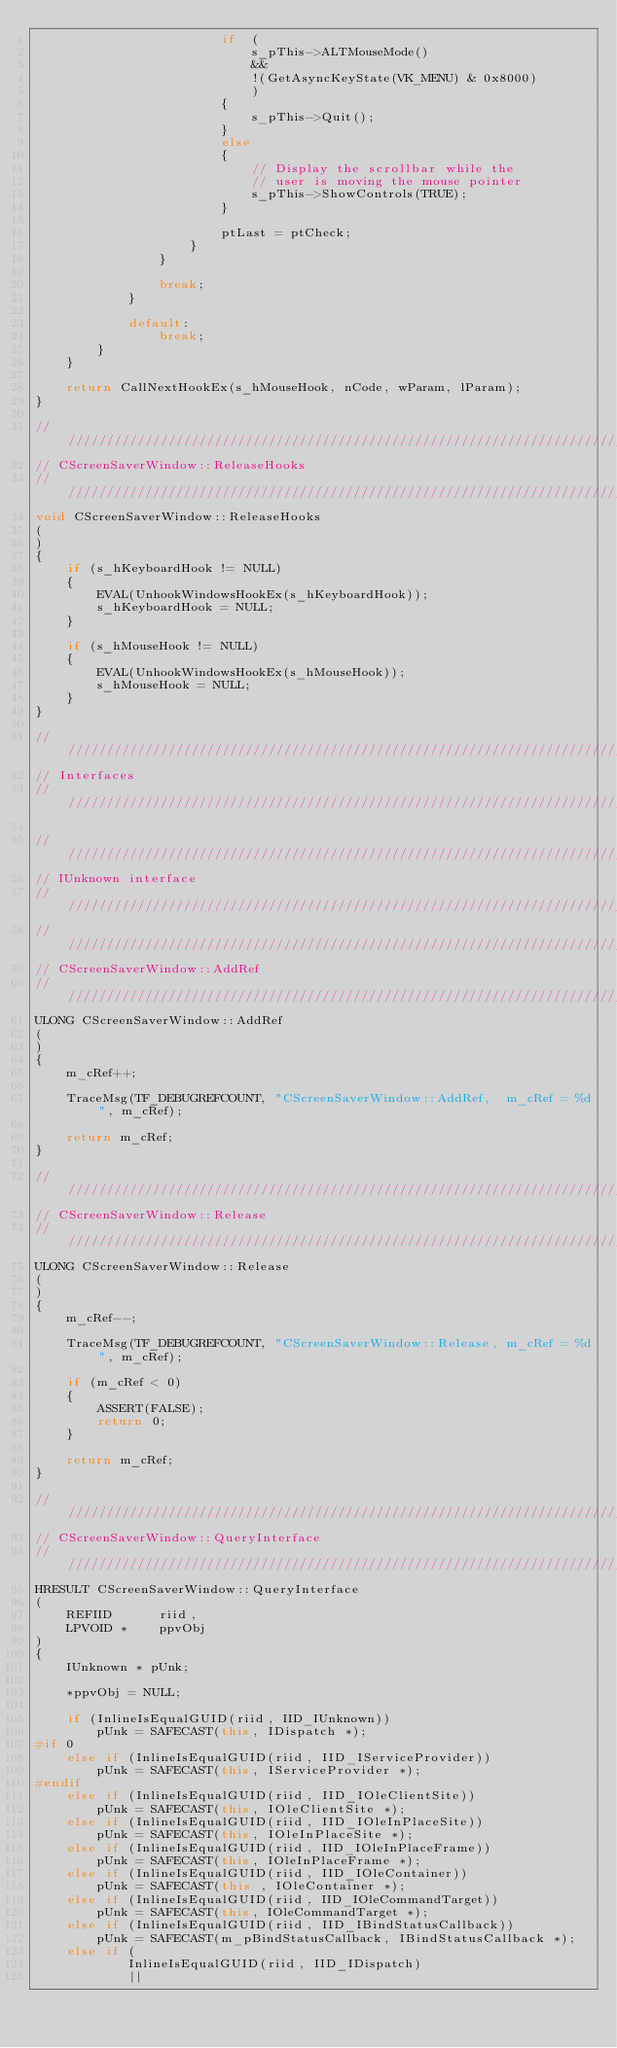Convert code to text. <code><loc_0><loc_0><loc_500><loc_500><_C++_>                        if  (
                            s_pThis->ALTMouseMode()
                            &&
                            !(GetAsyncKeyState(VK_MENU) & 0x8000)
                            )
                        {
                            s_pThis->Quit();
                        }
                        else
                        {
                            // Display the scrollbar while the
                            // user is moving the mouse pointer
                            s_pThis->ShowControls(TRUE);
                        }

                        ptLast = ptCheck;
                    }
                }

                break;
            }

            default:
                break;
        }
    }

    return CallNextHookEx(s_hMouseHook, nCode, wParam, lParam);
}

/////////////////////////////////////////////////////////////////////////////
// CScreenSaverWindow::ReleaseHooks
/////////////////////////////////////////////////////////////////////////////
void CScreenSaverWindow::ReleaseHooks
(
)
{
    if (s_hKeyboardHook != NULL)
    {
        EVAL(UnhookWindowsHookEx(s_hKeyboardHook));
        s_hKeyboardHook = NULL;
    }

    if (s_hMouseHook != NULL)
    {
        EVAL(UnhookWindowsHookEx(s_hMouseHook));
        s_hMouseHook = NULL;
    }
}

/////////////////////////////////////////////////////////////////////////////
// Interfaces
/////////////////////////////////////////////////////////////////////////////

/////////////////////////////////////////////////////////////////////////////
// IUnknown interface
/////////////////////////////////////////////////////////////////////////////
/////////////////////////////////////////////////////////////////////////////
// CScreenSaverWindow::AddRef
/////////////////////////////////////////////////////////////////////////////
ULONG CScreenSaverWindow::AddRef
(
) 
{
    m_cRef++;

    TraceMsg(TF_DEBUGREFCOUNT, "CScreenSaverWindow::AddRef,  m_cRef = %d", m_cRef);

    return m_cRef;
}

/////////////////////////////////////////////////////////////////////////////
// CScreenSaverWindow::Release
/////////////////////////////////////////////////////////////////////////////
ULONG CScreenSaverWindow::Release
(
)
{
    m_cRef--;

    TraceMsg(TF_DEBUGREFCOUNT, "CScreenSaverWindow::Release, m_cRef = %d", m_cRef);

    if (m_cRef < 0)
    {
        ASSERT(FALSE);
        return 0;
    }

    return m_cRef;
}

/////////////////////////////////////////////////////////////////////////////
// CScreenSaverWindow::QueryInterface
/////////////////////////////////////////////////////////////////////////////
HRESULT CScreenSaverWindow::QueryInterface
(
    REFIID      riid,
    LPVOID *    ppvObj
)
{
    IUnknown * pUnk;

    *ppvObj = NULL;

    if (InlineIsEqualGUID(riid, IID_IUnknown))
        pUnk = SAFECAST(this, IDispatch *);
#if 0
    else if (InlineIsEqualGUID(riid, IID_IServiceProvider))
        pUnk = SAFECAST(this, IServiceProvider *);
#endif
    else if (InlineIsEqualGUID(riid, IID_IOleClientSite))
        pUnk = SAFECAST(this, IOleClientSite *);
    else if (InlineIsEqualGUID(riid, IID_IOleInPlaceSite))
        pUnk = SAFECAST(this, IOleInPlaceSite *);
    else if (InlineIsEqualGUID(riid, IID_IOleInPlaceFrame))
        pUnk = SAFECAST(this, IOleInPlaceFrame *);
    else if (InlineIsEqualGUID(riid, IID_IOleContainer))
        pUnk = SAFECAST(this , IOleContainer *);
    else if (InlineIsEqualGUID(riid, IID_IOleCommandTarget))
        pUnk = SAFECAST(this, IOleCommandTarget *);
    else if (InlineIsEqualGUID(riid, IID_IBindStatusCallback))
        pUnk = SAFECAST(m_pBindStatusCallback, IBindStatusCallback *);
    else if (
            InlineIsEqualGUID(riid, IID_IDispatch)
            ||</code> 